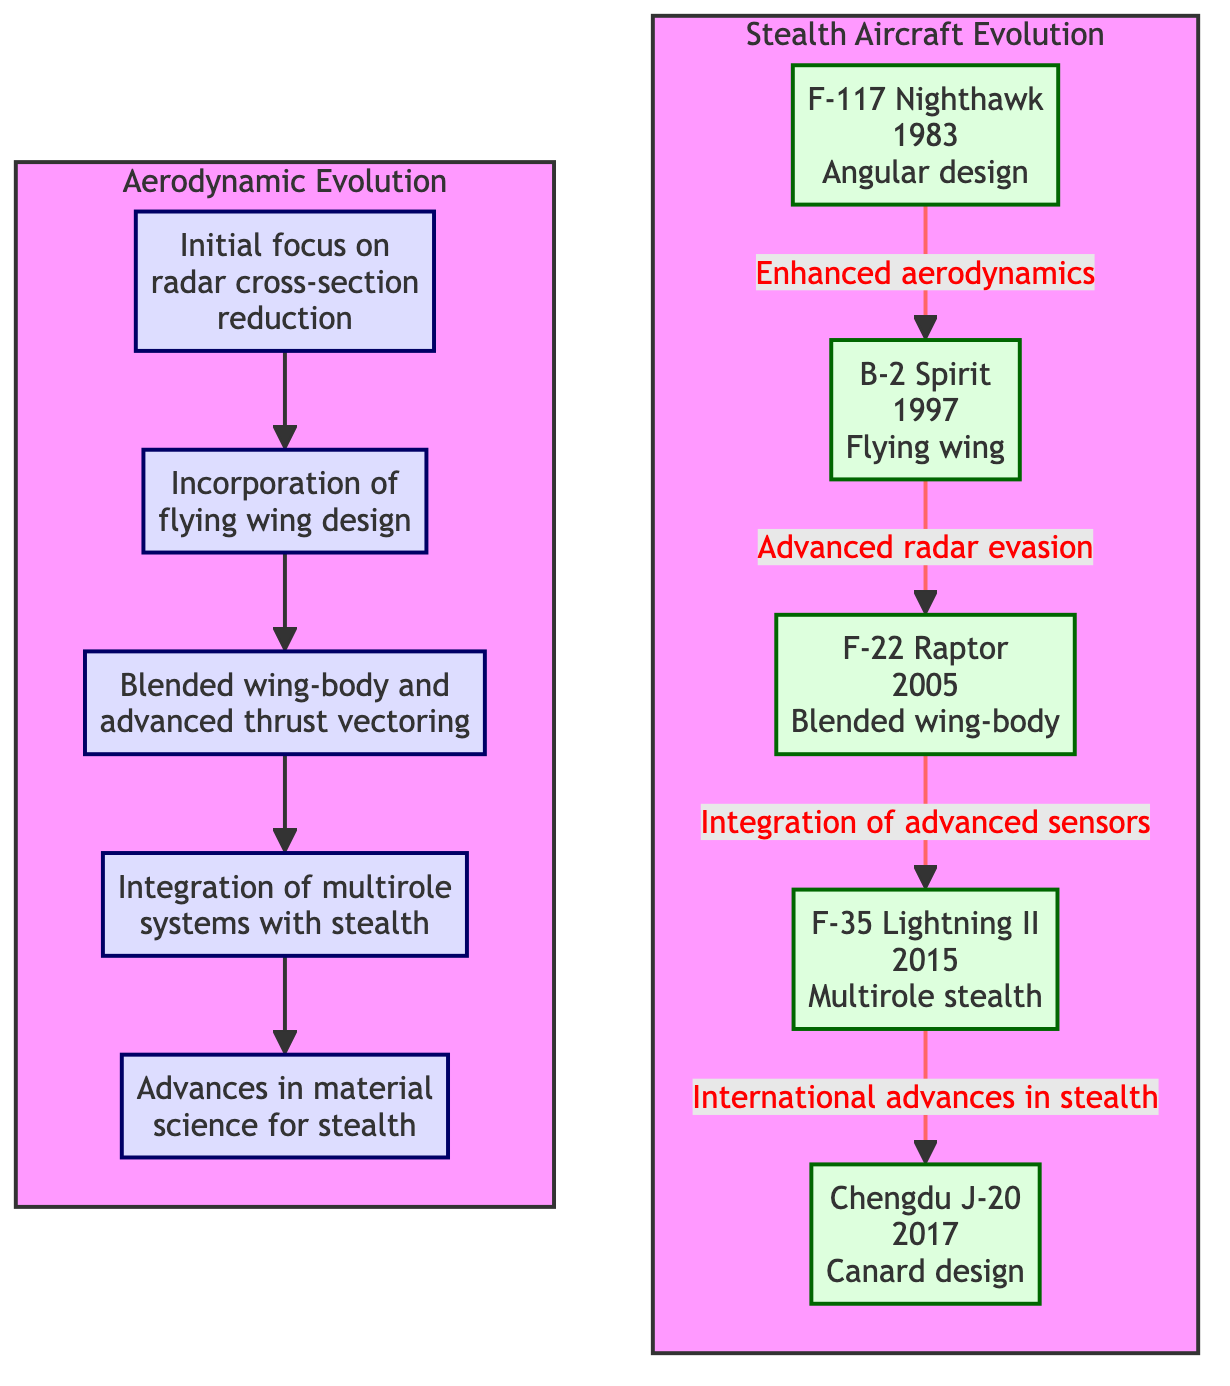What is the first aircraft listed in the stealth aircraft evolution? The first aircraft listed in the stealth aircraft evolution subgraph is the F-117 Nighthawk, which appears as node A1 at the top of the sequence.
Answer: F-117 Nighthawk What year was the F-35 Lightning II introduced? The F-35 Lightning II, labeled as A4 within the stealth aircraft evolution section, is indicated to have been introduced in 2015.
Answer: 2015 How many stealth aircraft designs are shown in the diagram? By counting the entries in the "Stealth Aircraft Evolution" subgraph, there are five distinct aircraft listed: F-117 Nighthawk, B-2 Spirit, F-22 Raptor, F-35 Lightning II, and Chengdu J-20, which gives a total of five.
Answer: 5 What design feature is a characteristic of the B-2 Spirit? The diagram notes that the B-2 Spirit, represented as A2, has a flying wing design, which is emphasized as its distinct characteristic in the description.
Answer: Flying wing Which stealth aircraft design introduced advanced radar evasion? The F-22 Raptor, shown as A3, is linked to the concept of advanced radar evasion, as indicated in the connection between nodes A2 and A3 in the diagram.
Answer: F-22 Raptor What type of evolution does the subgraph "Aerodynamic Evolution" focus on? The "Aerodynamic Evolution" subgraph outlines the progression of aircraft design with respect to aerodynamics, beginning from radar cross-section reduction and culminating in advances in material science for stealth.
Answer: Aerodynamics Which stealth aircraft was introduced in 2017? The Chengdu J-20, denoted as A5 in the diagram, is indicated to have been introduced in 2017.
Answer: Chengdu J-20 What process is described in the connection from F-3 to F4? The connection from F-3 to F-4 indicates the integration of multirole systems with stealth, as highlighted in the explanation of the aerodynamic evolution in that flowchart segment.
Answer: Integration of multirole systems with stealth What technological advancement links the F-22 Raptor and the F-35 Lightning II? The technological advancement linking these two aircraft, from F-3 to A4, involves the integration of advanced sensors, which represents an evolutionary progress in stealth technology from F-22 to F-35.
Answer: Integration of advanced sensors 